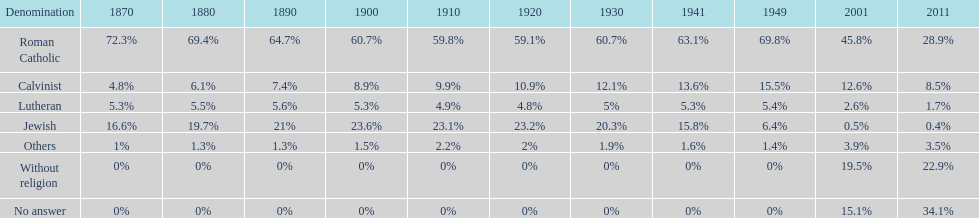Which sect has the greatest margin? Roman Catholic. Would you mind parsing the complete table? {'header': ['Denomination', '1870', '1880', '1890', '1900', '1910', '1920', '1930', '1941', '1949', '2001', '2011'], 'rows': [['Roman Catholic', '72.3%', '69.4%', '64.7%', '60.7%', '59.8%', '59.1%', '60.7%', '63.1%', '69.8%', '45.8%', '28.9%'], ['Calvinist', '4.8%', '6.1%', '7.4%', '8.9%', '9.9%', '10.9%', '12.1%', '13.6%', '15.5%', '12.6%', '8.5%'], ['Lutheran', '5.3%', '5.5%', '5.6%', '5.3%', '4.9%', '4.8%', '5%', '5.3%', '5.4%', '2.6%', '1.7%'], ['Jewish', '16.6%', '19.7%', '21%', '23.6%', '23.1%', '23.2%', '20.3%', '15.8%', '6.4%', '0.5%', '0.4%'], ['Others', '1%', '1.3%', '1.3%', '1.5%', '2.2%', '2%', '1.9%', '1.6%', '1.4%', '3.9%', '3.5%'], ['Without religion', '0%', '0%', '0%', '0%', '0%', '0%', '0%', '0%', '0%', '19.5%', '22.9%'], ['No answer', '0%', '0%', '0%', '0%', '0%', '0%', '0%', '0%', '0%', '15.1%', '34.1%']]} 